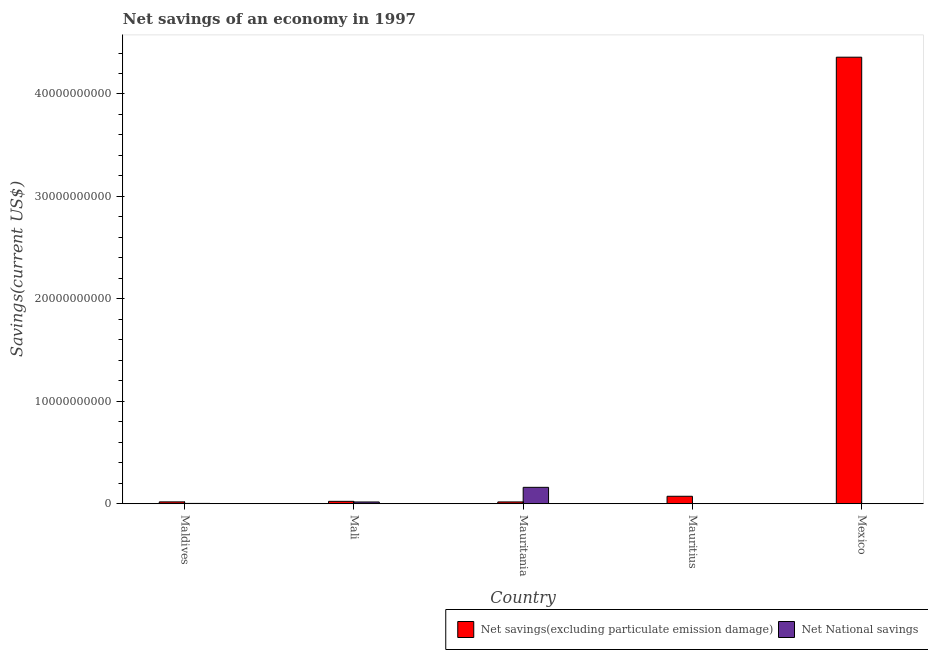How many different coloured bars are there?
Provide a succinct answer. 2. Are the number of bars per tick equal to the number of legend labels?
Provide a short and direct response. No. Are the number of bars on each tick of the X-axis equal?
Keep it short and to the point. No. How many bars are there on the 4th tick from the right?
Make the answer very short. 2. What is the label of the 3rd group of bars from the left?
Your response must be concise. Mauritania. In how many cases, is the number of bars for a given country not equal to the number of legend labels?
Provide a succinct answer. 2. What is the net national savings in Maldives?
Offer a very short reply. 3.15e+07. Across all countries, what is the maximum net national savings?
Give a very brief answer. 1.60e+09. Across all countries, what is the minimum net savings(excluding particulate emission damage)?
Provide a short and direct response. 1.78e+08. In which country was the net national savings maximum?
Ensure brevity in your answer.  Mauritania. What is the total net national savings in the graph?
Provide a short and direct response. 1.81e+09. What is the difference between the net national savings in Maldives and that in Mali?
Your answer should be very brief. -1.42e+08. What is the difference between the net savings(excluding particulate emission damage) in Mauritania and the net national savings in Mauritius?
Provide a succinct answer. 1.78e+08. What is the average net national savings per country?
Provide a short and direct response. 3.61e+08. What is the difference between the net national savings and net savings(excluding particulate emission damage) in Maldives?
Make the answer very short. -1.50e+08. In how many countries, is the net national savings greater than 8000000000 US$?
Keep it short and to the point. 0. What is the ratio of the net savings(excluding particulate emission damage) in Maldives to that in Mauritania?
Offer a terse response. 1.02. Is the net national savings in Maldives less than that in Mauritania?
Your response must be concise. Yes. Is the difference between the net national savings in Mali and Mauritania greater than the difference between the net savings(excluding particulate emission damage) in Mali and Mauritania?
Your answer should be very brief. No. What is the difference between the highest and the second highest net national savings?
Offer a very short reply. 1.43e+09. What is the difference between the highest and the lowest net savings(excluding particulate emission damage)?
Provide a short and direct response. 4.34e+1. How many bars are there?
Offer a very short reply. 8. How many countries are there in the graph?
Keep it short and to the point. 5. What is the difference between two consecutive major ticks on the Y-axis?
Your response must be concise. 1.00e+1. Does the graph contain any zero values?
Make the answer very short. Yes. Does the graph contain grids?
Ensure brevity in your answer.  No. What is the title of the graph?
Provide a succinct answer. Net savings of an economy in 1997. What is the label or title of the Y-axis?
Ensure brevity in your answer.  Savings(current US$). What is the Savings(current US$) in Net savings(excluding particulate emission damage) in Maldives?
Provide a succinct answer. 1.81e+08. What is the Savings(current US$) in Net National savings in Maldives?
Offer a very short reply. 3.15e+07. What is the Savings(current US$) of Net savings(excluding particulate emission damage) in Mali?
Keep it short and to the point. 2.34e+08. What is the Savings(current US$) in Net National savings in Mali?
Provide a succinct answer. 1.73e+08. What is the Savings(current US$) of Net savings(excluding particulate emission damage) in Mauritania?
Your response must be concise. 1.78e+08. What is the Savings(current US$) in Net National savings in Mauritania?
Provide a short and direct response. 1.60e+09. What is the Savings(current US$) of Net savings(excluding particulate emission damage) in Mauritius?
Provide a short and direct response. 7.29e+08. What is the Savings(current US$) in Net National savings in Mauritius?
Make the answer very short. 0. What is the Savings(current US$) of Net savings(excluding particulate emission damage) in Mexico?
Make the answer very short. 4.36e+1. What is the Savings(current US$) in Net National savings in Mexico?
Give a very brief answer. 0. Across all countries, what is the maximum Savings(current US$) in Net savings(excluding particulate emission damage)?
Your answer should be very brief. 4.36e+1. Across all countries, what is the maximum Savings(current US$) in Net National savings?
Your answer should be compact. 1.60e+09. Across all countries, what is the minimum Savings(current US$) of Net savings(excluding particulate emission damage)?
Your answer should be compact. 1.78e+08. Across all countries, what is the minimum Savings(current US$) in Net National savings?
Keep it short and to the point. 0. What is the total Savings(current US$) in Net savings(excluding particulate emission damage) in the graph?
Your response must be concise. 4.49e+1. What is the total Savings(current US$) in Net National savings in the graph?
Provide a succinct answer. 1.81e+09. What is the difference between the Savings(current US$) of Net savings(excluding particulate emission damage) in Maldives and that in Mali?
Your answer should be compact. -5.30e+07. What is the difference between the Savings(current US$) of Net National savings in Maldives and that in Mali?
Give a very brief answer. -1.42e+08. What is the difference between the Savings(current US$) of Net savings(excluding particulate emission damage) in Maldives and that in Mauritania?
Your answer should be compact. 3.62e+06. What is the difference between the Savings(current US$) of Net National savings in Maldives and that in Mauritania?
Keep it short and to the point. -1.57e+09. What is the difference between the Savings(current US$) of Net savings(excluding particulate emission damage) in Maldives and that in Mauritius?
Provide a short and direct response. -5.48e+08. What is the difference between the Savings(current US$) in Net savings(excluding particulate emission damage) in Maldives and that in Mexico?
Offer a terse response. -4.34e+1. What is the difference between the Savings(current US$) in Net savings(excluding particulate emission damage) in Mali and that in Mauritania?
Your answer should be compact. 5.66e+07. What is the difference between the Savings(current US$) of Net National savings in Mali and that in Mauritania?
Your answer should be compact. -1.43e+09. What is the difference between the Savings(current US$) of Net savings(excluding particulate emission damage) in Mali and that in Mauritius?
Provide a short and direct response. -4.95e+08. What is the difference between the Savings(current US$) of Net savings(excluding particulate emission damage) in Mali and that in Mexico?
Make the answer very short. -4.34e+1. What is the difference between the Savings(current US$) of Net savings(excluding particulate emission damage) in Mauritania and that in Mauritius?
Make the answer very short. -5.52e+08. What is the difference between the Savings(current US$) of Net savings(excluding particulate emission damage) in Mauritania and that in Mexico?
Provide a succinct answer. -4.34e+1. What is the difference between the Savings(current US$) of Net savings(excluding particulate emission damage) in Mauritius and that in Mexico?
Provide a short and direct response. -4.29e+1. What is the difference between the Savings(current US$) in Net savings(excluding particulate emission damage) in Maldives and the Savings(current US$) in Net National savings in Mali?
Your answer should be very brief. 8.42e+06. What is the difference between the Savings(current US$) in Net savings(excluding particulate emission damage) in Maldives and the Savings(current US$) in Net National savings in Mauritania?
Offer a very short reply. -1.42e+09. What is the difference between the Savings(current US$) in Net savings(excluding particulate emission damage) in Mali and the Savings(current US$) in Net National savings in Mauritania?
Your answer should be very brief. -1.37e+09. What is the average Savings(current US$) in Net savings(excluding particulate emission damage) per country?
Give a very brief answer. 8.98e+09. What is the average Savings(current US$) of Net National savings per country?
Keep it short and to the point. 3.61e+08. What is the difference between the Savings(current US$) in Net savings(excluding particulate emission damage) and Savings(current US$) in Net National savings in Maldives?
Your answer should be compact. 1.50e+08. What is the difference between the Savings(current US$) of Net savings(excluding particulate emission damage) and Savings(current US$) of Net National savings in Mali?
Keep it short and to the point. 6.14e+07. What is the difference between the Savings(current US$) in Net savings(excluding particulate emission damage) and Savings(current US$) in Net National savings in Mauritania?
Your response must be concise. -1.42e+09. What is the ratio of the Savings(current US$) of Net savings(excluding particulate emission damage) in Maldives to that in Mali?
Make the answer very short. 0.77. What is the ratio of the Savings(current US$) of Net National savings in Maldives to that in Mali?
Provide a short and direct response. 0.18. What is the ratio of the Savings(current US$) in Net savings(excluding particulate emission damage) in Maldives to that in Mauritania?
Your response must be concise. 1.02. What is the ratio of the Savings(current US$) of Net National savings in Maldives to that in Mauritania?
Keep it short and to the point. 0.02. What is the ratio of the Savings(current US$) in Net savings(excluding particulate emission damage) in Maldives to that in Mauritius?
Offer a very short reply. 0.25. What is the ratio of the Savings(current US$) in Net savings(excluding particulate emission damage) in Maldives to that in Mexico?
Ensure brevity in your answer.  0. What is the ratio of the Savings(current US$) of Net savings(excluding particulate emission damage) in Mali to that in Mauritania?
Provide a short and direct response. 1.32. What is the ratio of the Savings(current US$) in Net National savings in Mali to that in Mauritania?
Your response must be concise. 0.11. What is the ratio of the Savings(current US$) in Net savings(excluding particulate emission damage) in Mali to that in Mauritius?
Provide a short and direct response. 0.32. What is the ratio of the Savings(current US$) in Net savings(excluding particulate emission damage) in Mali to that in Mexico?
Offer a very short reply. 0.01. What is the ratio of the Savings(current US$) of Net savings(excluding particulate emission damage) in Mauritania to that in Mauritius?
Offer a very short reply. 0.24. What is the ratio of the Savings(current US$) in Net savings(excluding particulate emission damage) in Mauritania to that in Mexico?
Your answer should be very brief. 0. What is the ratio of the Savings(current US$) of Net savings(excluding particulate emission damage) in Mauritius to that in Mexico?
Make the answer very short. 0.02. What is the difference between the highest and the second highest Savings(current US$) of Net savings(excluding particulate emission damage)?
Give a very brief answer. 4.29e+1. What is the difference between the highest and the second highest Savings(current US$) in Net National savings?
Your response must be concise. 1.43e+09. What is the difference between the highest and the lowest Savings(current US$) of Net savings(excluding particulate emission damage)?
Your answer should be compact. 4.34e+1. What is the difference between the highest and the lowest Savings(current US$) of Net National savings?
Your answer should be compact. 1.60e+09. 